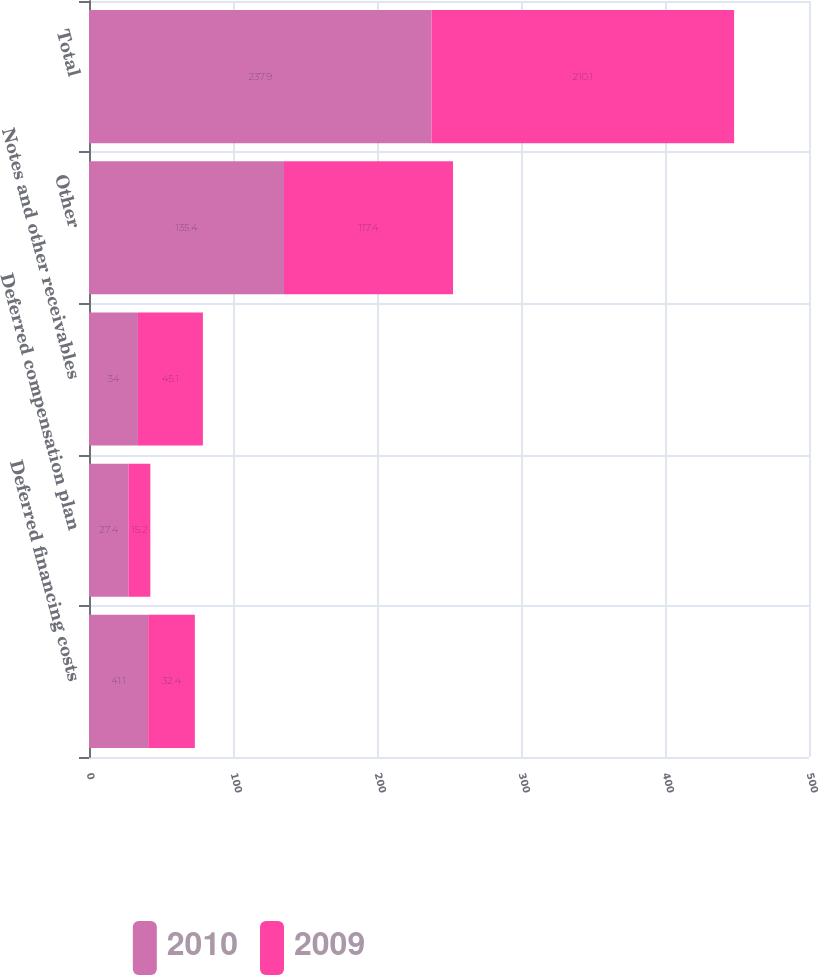Convert chart. <chart><loc_0><loc_0><loc_500><loc_500><stacked_bar_chart><ecel><fcel>Deferred financing costs<fcel>Deferred compensation plan<fcel>Notes and other receivables<fcel>Other<fcel>Total<nl><fcel>2010<fcel>41.1<fcel>27.4<fcel>34<fcel>135.4<fcel>237.9<nl><fcel>2009<fcel>32.4<fcel>15.2<fcel>45.1<fcel>117.4<fcel>210.1<nl></chart> 